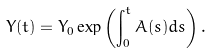<formula> <loc_0><loc_0><loc_500><loc_500>Y ( t ) = Y _ { 0 } \exp \left ( \int _ { 0 } ^ { t } A ( s ) d s \right ) .</formula> 